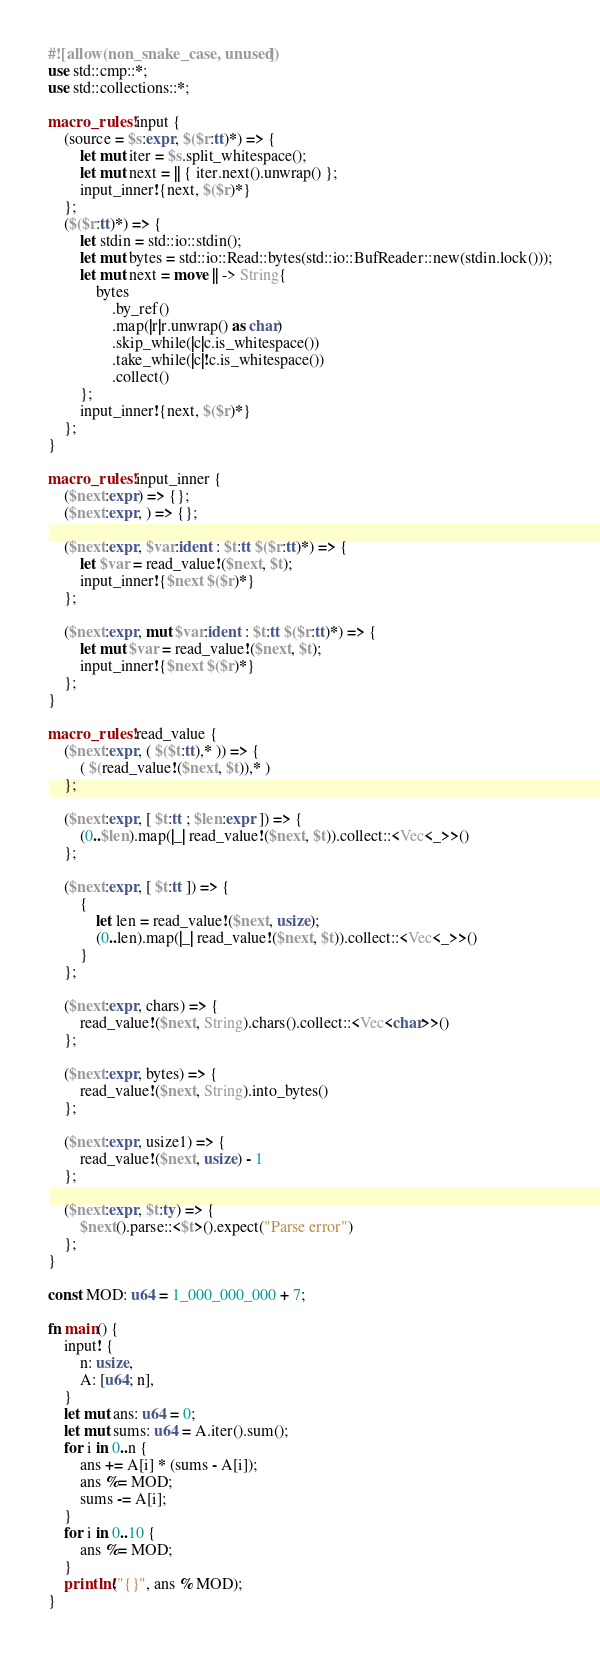Convert code to text. <code><loc_0><loc_0><loc_500><loc_500><_Rust_>#![allow(non_snake_case, unused)]
use std::cmp::*;
use std::collections::*;

macro_rules! input {
    (source = $s:expr, $($r:tt)*) => {
        let mut iter = $s.split_whitespace();
        let mut next = || { iter.next().unwrap() };
        input_inner!{next, $($r)*}
    };
    ($($r:tt)*) => {
        let stdin = std::io::stdin();
        let mut bytes = std::io::Read::bytes(std::io::BufReader::new(stdin.lock()));
        let mut next = move || -> String{
            bytes
                .by_ref()
                .map(|r|r.unwrap() as char)
                .skip_while(|c|c.is_whitespace())
                .take_while(|c|!c.is_whitespace())
                .collect()
        };
        input_inner!{next, $($r)*}
    };
}

macro_rules! input_inner {
    ($next:expr) => {};
    ($next:expr, ) => {};

    ($next:expr, $var:ident : $t:tt $($r:tt)*) => {
        let $var = read_value!($next, $t);
        input_inner!{$next $($r)*}
    };

    ($next:expr, mut $var:ident : $t:tt $($r:tt)*) => {
        let mut $var = read_value!($next, $t);
        input_inner!{$next $($r)*}
    };
}

macro_rules! read_value {
    ($next:expr, ( $($t:tt),* )) => {
        ( $(read_value!($next, $t)),* )
    };

    ($next:expr, [ $t:tt ; $len:expr ]) => {
        (0..$len).map(|_| read_value!($next, $t)).collect::<Vec<_>>()
    };

    ($next:expr, [ $t:tt ]) => {
        {
            let len = read_value!($next, usize);
            (0..len).map(|_| read_value!($next, $t)).collect::<Vec<_>>()
        }
    };

    ($next:expr, chars) => {
        read_value!($next, String).chars().collect::<Vec<char>>()
    };

    ($next:expr, bytes) => {
        read_value!($next, String).into_bytes()
    };

    ($next:expr, usize1) => {
        read_value!($next, usize) - 1
    };

    ($next:expr, $t:ty) => {
        $next().parse::<$t>().expect("Parse error")
    };
}

const MOD: u64 = 1_000_000_000 + 7;

fn main() {
    input! {
        n: usize,
        A: [u64; n],
    }
    let mut ans: u64 = 0;
    let mut sums: u64 = A.iter().sum();
    for i in 0..n {
        ans += A[i] * (sums - A[i]);
        ans %= MOD;
        sums -= A[i];
    }
    for i in 0..10 {
        ans %= MOD;
    }
    println!("{}", ans % MOD);
}
</code> 